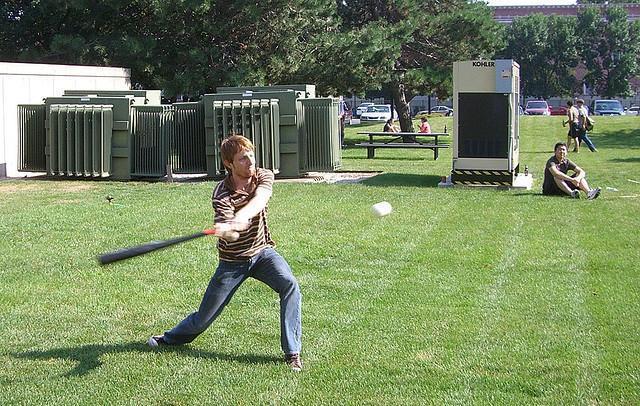What does the unit named Kohler provide?
Answer the question by selecting the correct answer among the 4 following choices.
Options: Water, electricity, heat, air conditioning. Air conditioning. 